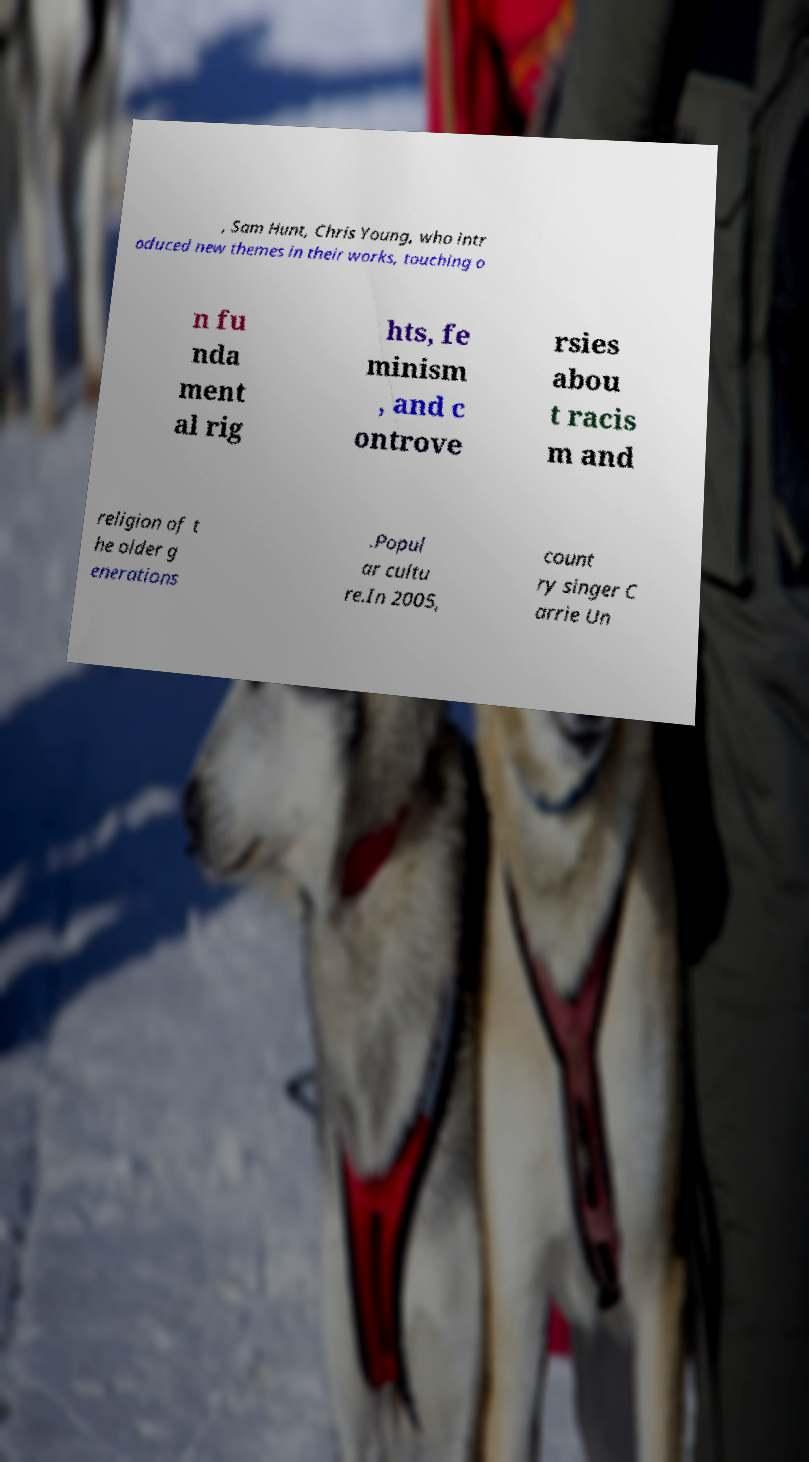For documentation purposes, I need the text within this image transcribed. Could you provide that? , Sam Hunt, Chris Young, who intr oduced new themes in their works, touching o n fu nda ment al rig hts, fe minism , and c ontrove rsies abou t racis m and religion of t he older g enerations .Popul ar cultu re.In 2005, count ry singer C arrie Un 